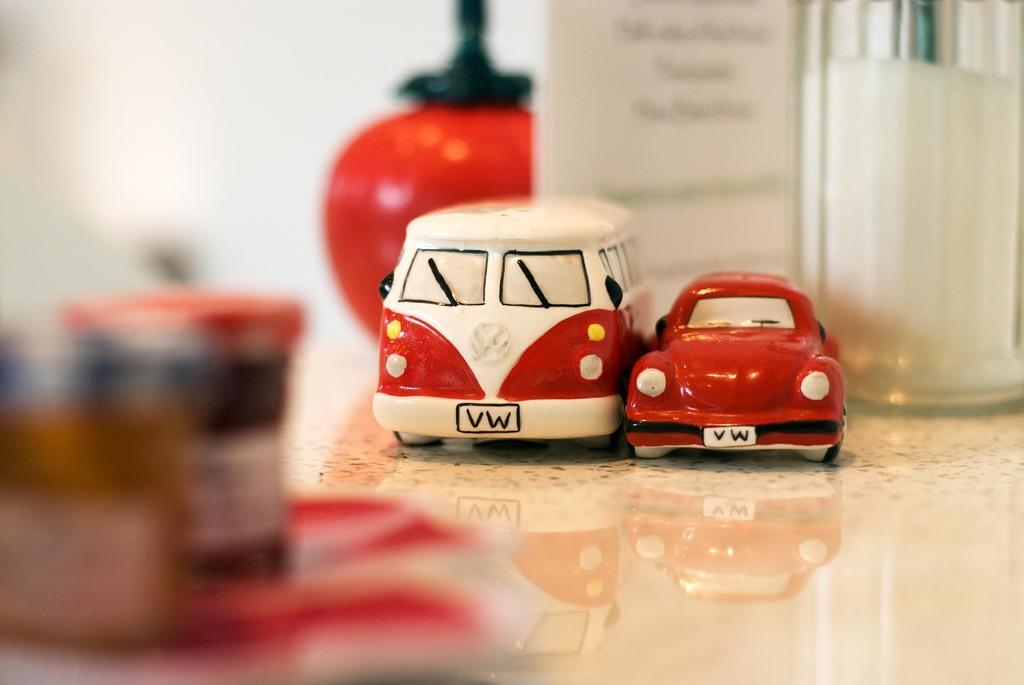Can you describe this image briefly? In this image we can see the toy vehicles and also we can see some other objects on the floor, in the background, we can see the wall. 